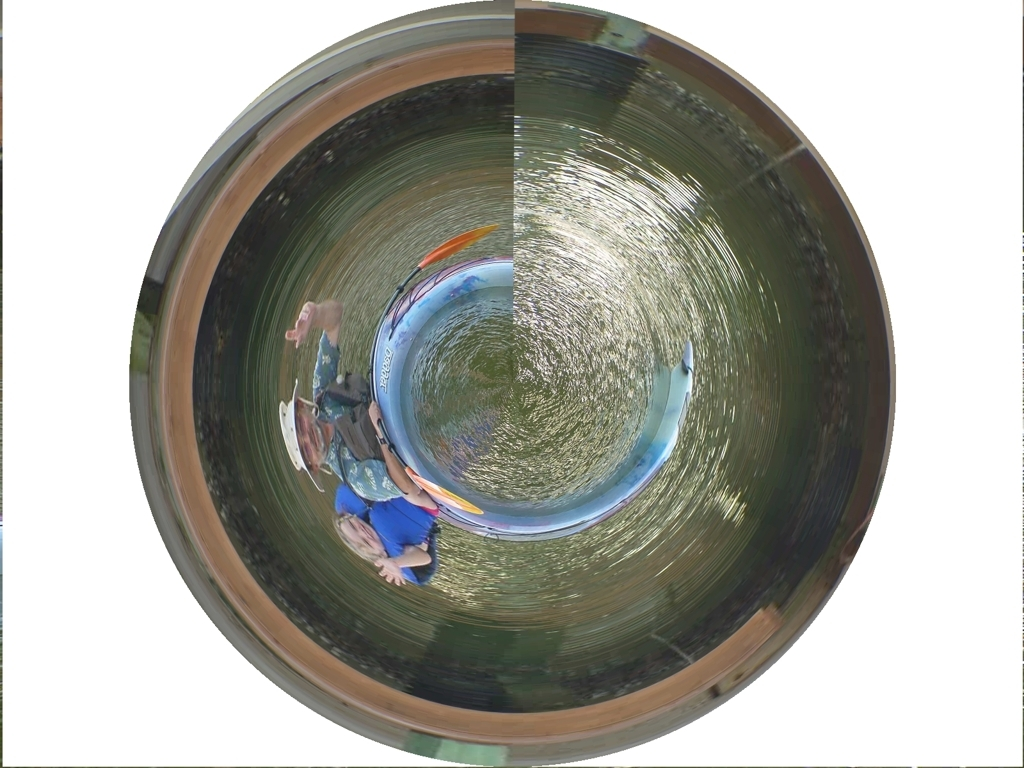Could you describe the unusual effect in the photograph? Certainly! The photograph features a 'tiny planet' effect, a form of post-processing where the image is manipulated to look spherical, as though the scene is taking place on a miniature planet. This is often achieved through a 360-degree panoramic picture that is wrapped around itself using special software or applications. 